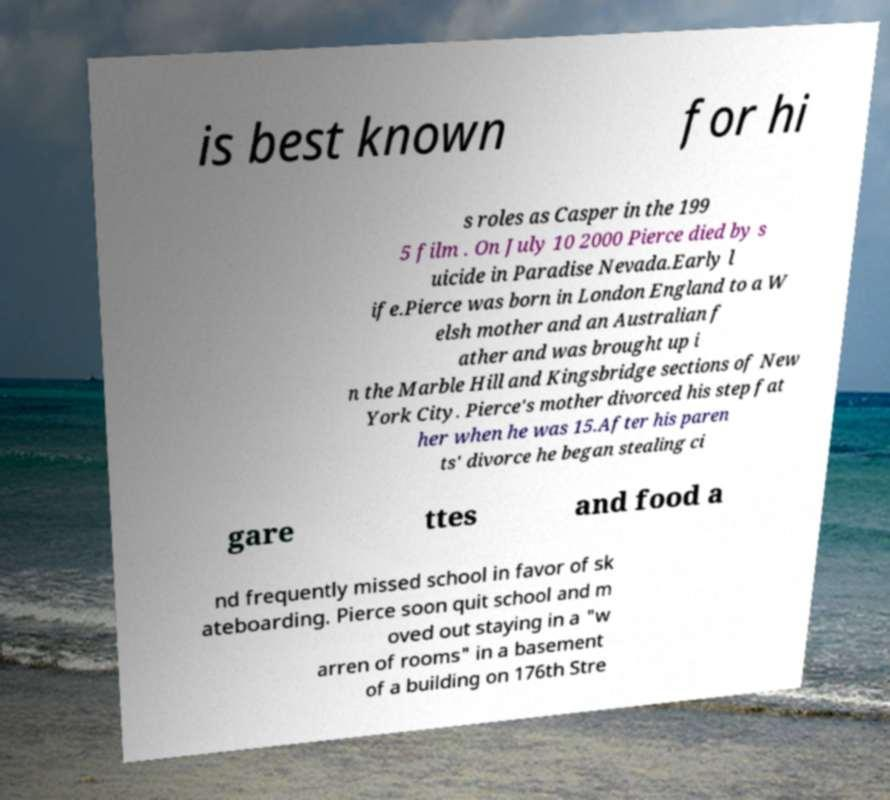For documentation purposes, I need the text within this image transcribed. Could you provide that? is best known for hi s roles as Casper in the 199 5 film . On July 10 2000 Pierce died by s uicide in Paradise Nevada.Early l ife.Pierce was born in London England to a W elsh mother and an Australian f ather and was brought up i n the Marble Hill and Kingsbridge sections of New York City. Pierce's mother divorced his step fat her when he was 15.After his paren ts' divorce he began stealing ci gare ttes and food a nd frequently missed school in favor of sk ateboarding. Pierce soon quit school and m oved out staying in a "w arren of rooms" in a basement of a building on 176th Stre 